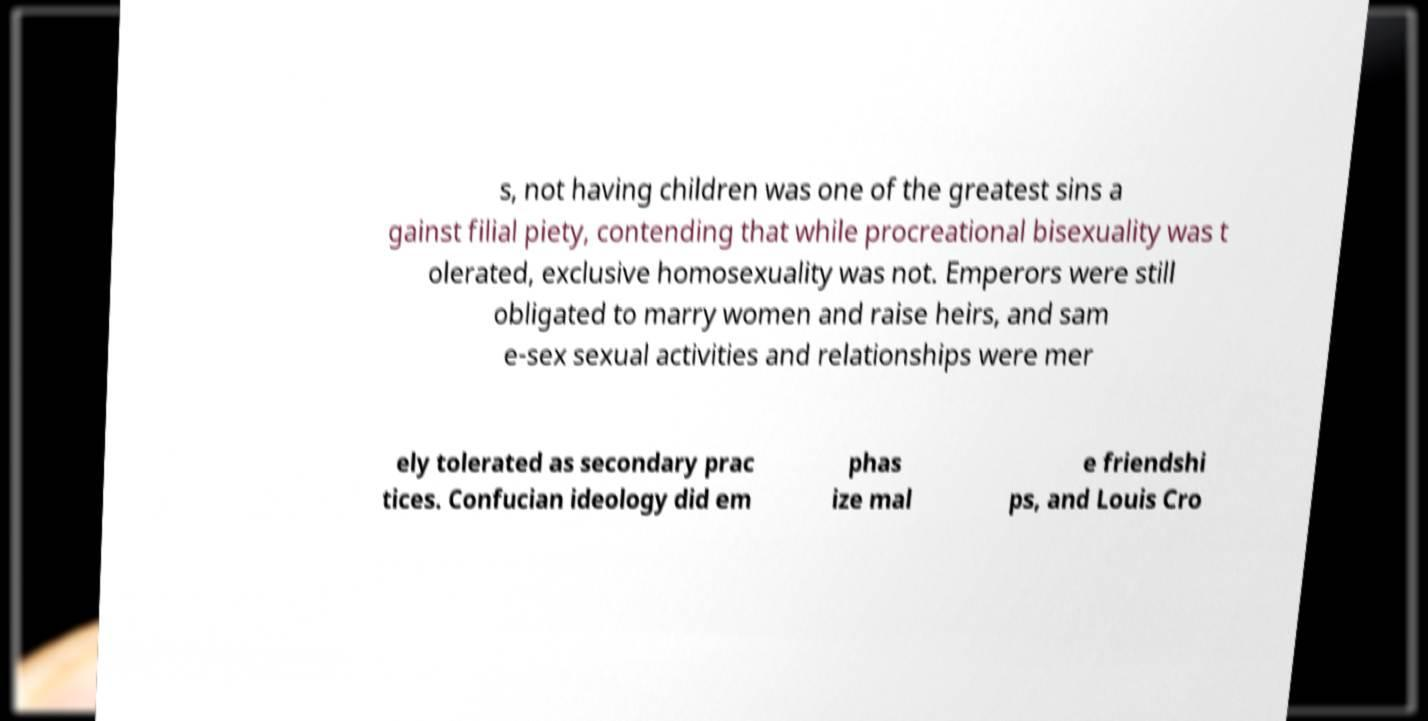Can you read and provide the text displayed in the image?This photo seems to have some interesting text. Can you extract and type it out for me? s, not having children was one of the greatest sins a gainst filial piety, contending that while procreational bisexuality was t olerated, exclusive homosexuality was not. Emperors were still obligated to marry women and raise heirs, and sam e-sex sexual activities and relationships were mer ely tolerated as secondary prac tices. Confucian ideology did em phas ize mal e friendshi ps, and Louis Cro 